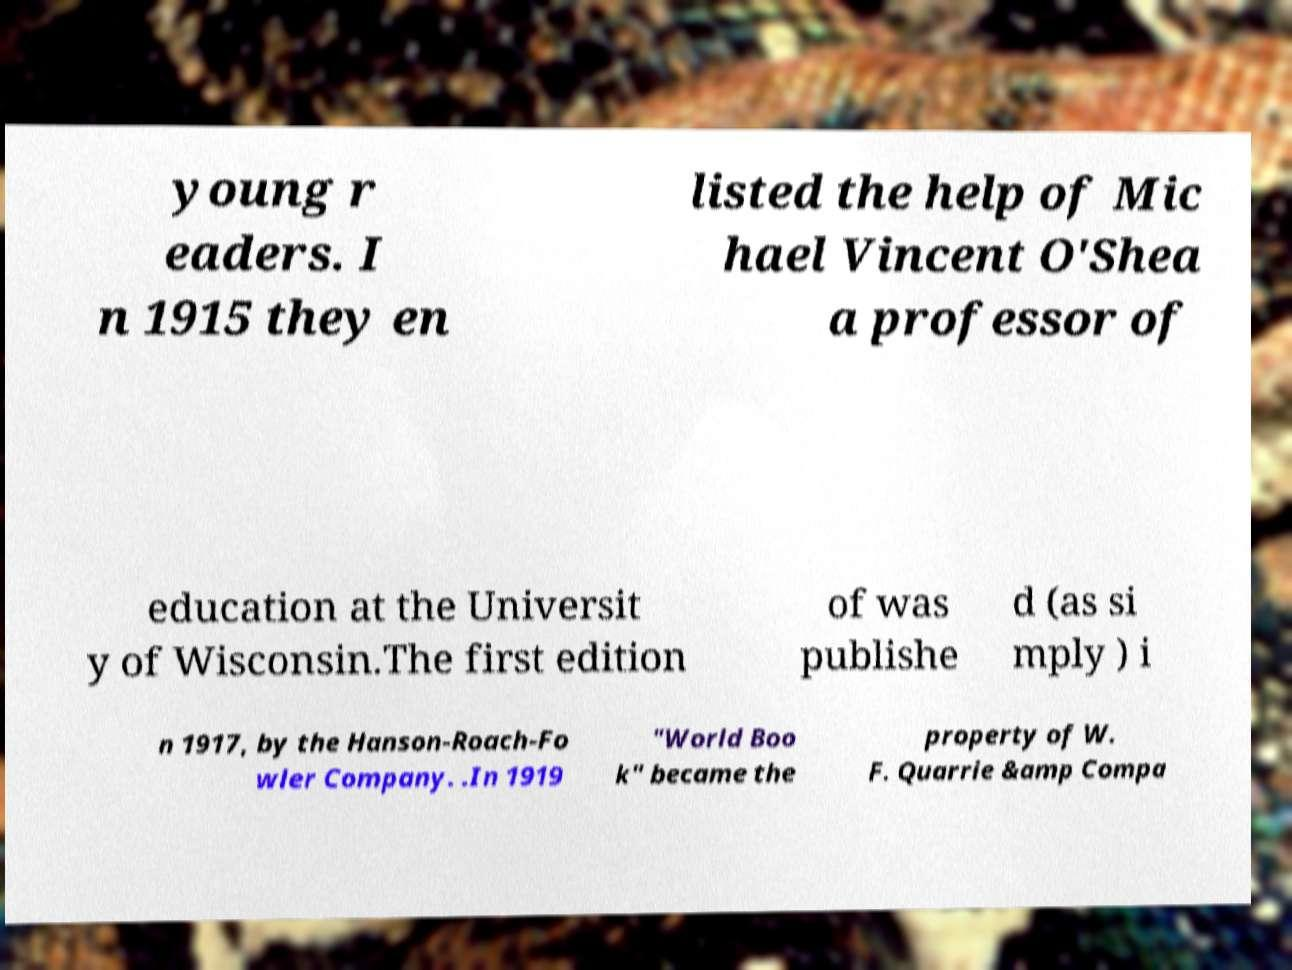Can you read and provide the text displayed in the image?This photo seems to have some interesting text. Can you extract and type it out for me? young r eaders. I n 1915 they en listed the help of Mic hael Vincent O'Shea a professor of education at the Universit y of Wisconsin.The first edition of was publishe d (as si mply ) i n 1917, by the Hanson-Roach-Fo wler Company. .In 1919 "World Boo k" became the property of W. F. Quarrie &amp Compa 